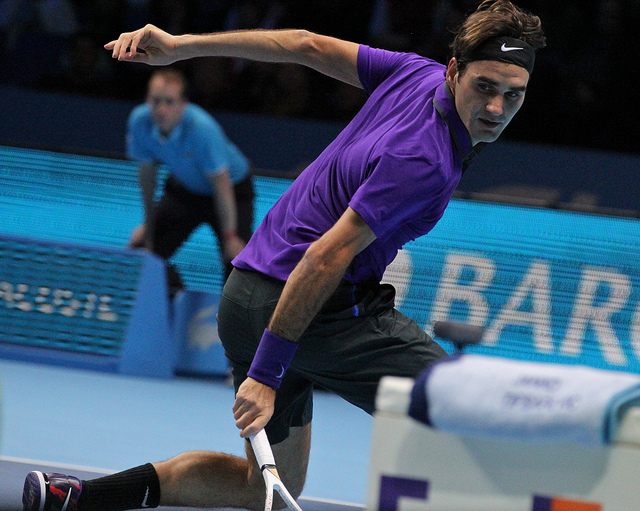Extract all visible text content from this image. BAR 